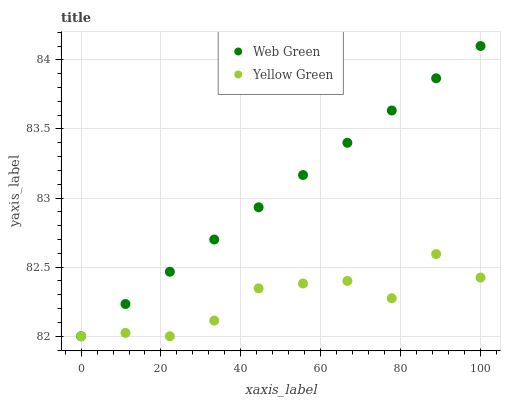Does Yellow Green have the minimum area under the curve?
Answer yes or no. Yes. Does Web Green have the maximum area under the curve?
Answer yes or no. Yes. Does Web Green have the minimum area under the curve?
Answer yes or no. No. Is Web Green the smoothest?
Answer yes or no. Yes. Is Yellow Green the roughest?
Answer yes or no. Yes. Is Web Green the roughest?
Answer yes or no. No. Does Yellow Green have the lowest value?
Answer yes or no. Yes. Does Web Green have the highest value?
Answer yes or no. Yes. Does Yellow Green intersect Web Green?
Answer yes or no. Yes. Is Yellow Green less than Web Green?
Answer yes or no. No. Is Yellow Green greater than Web Green?
Answer yes or no. No. 